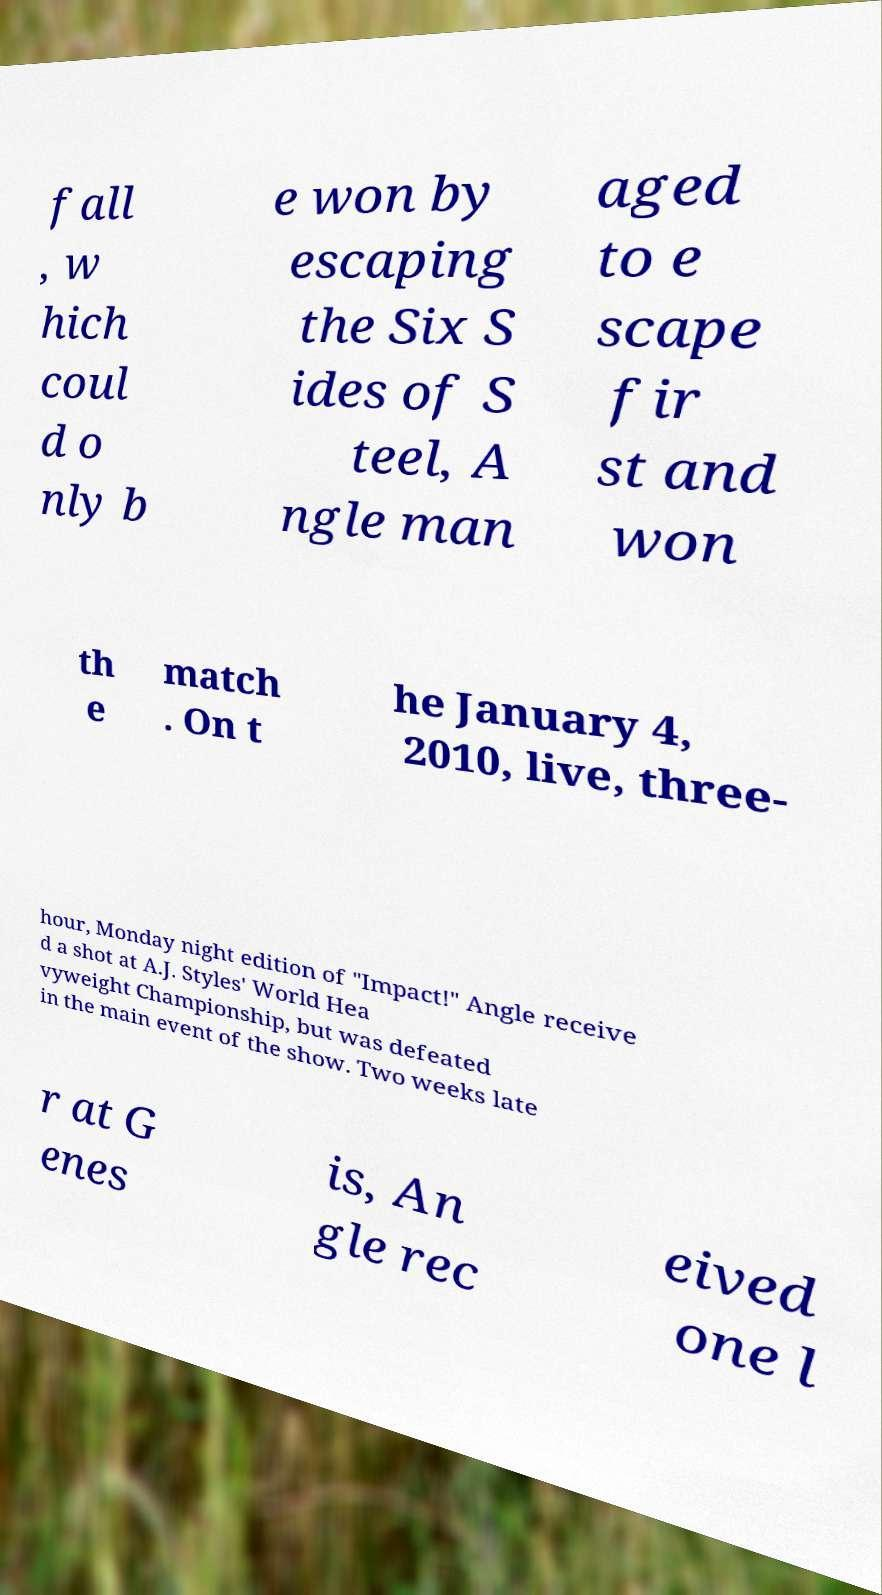Can you read and provide the text displayed in the image?This photo seems to have some interesting text. Can you extract and type it out for me? fall , w hich coul d o nly b e won by escaping the Six S ides of S teel, A ngle man aged to e scape fir st and won th e match . On t he January 4, 2010, live, three- hour, Monday night edition of "Impact!" Angle receive d a shot at A.J. Styles' World Hea vyweight Championship, but was defeated in the main event of the show. Two weeks late r at G enes is, An gle rec eived one l 